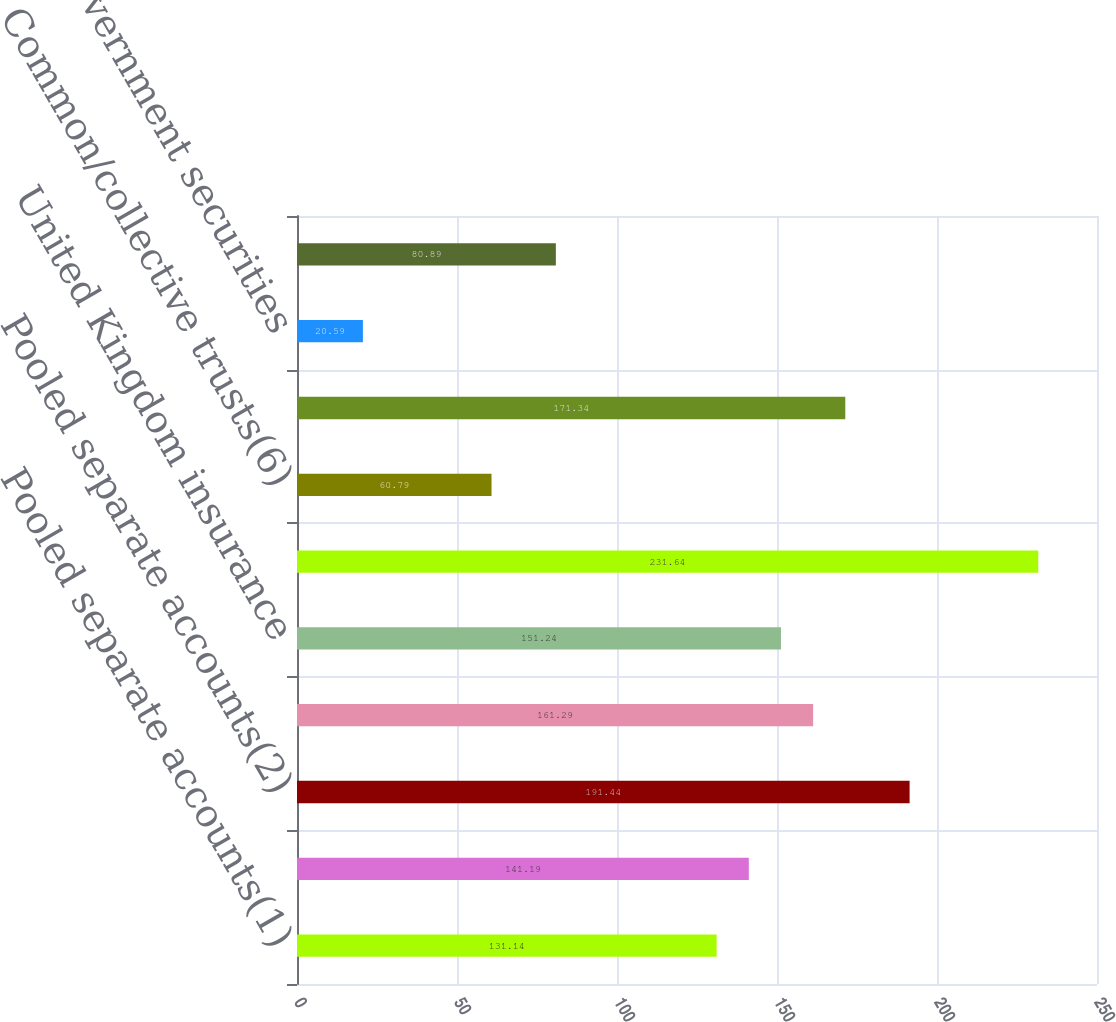Convert chart to OTSL. <chart><loc_0><loc_0><loc_500><loc_500><bar_chart><fcel>Pooled separate accounts(1)<fcel>Common/collective trusts(1)<fcel>Pooled separate accounts(2)<fcel>Common/collective trusts(3)<fcel>United Kingdom insurance<fcel>Pooled separate accounts(5)<fcel>Common/collective trusts(6)<fcel>Mortgage-backed<fcel>Other US government securities<fcel>US government securities<nl><fcel>131.14<fcel>141.19<fcel>191.44<fcel>161.29<fcel>151.24<fcel>231.64<fcel>60.79<fcel>171.34<fcel>20.59<fcel>80.89<nl></chart> 